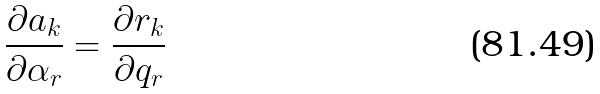<formula> <loc_0><loc_0><loc_500><loc_500>\frac { \partial a _ { k } } { \partial \alpha _ { r } } = \frac { \partial r _ { k } } { \partial q _ { r } }</formula> 